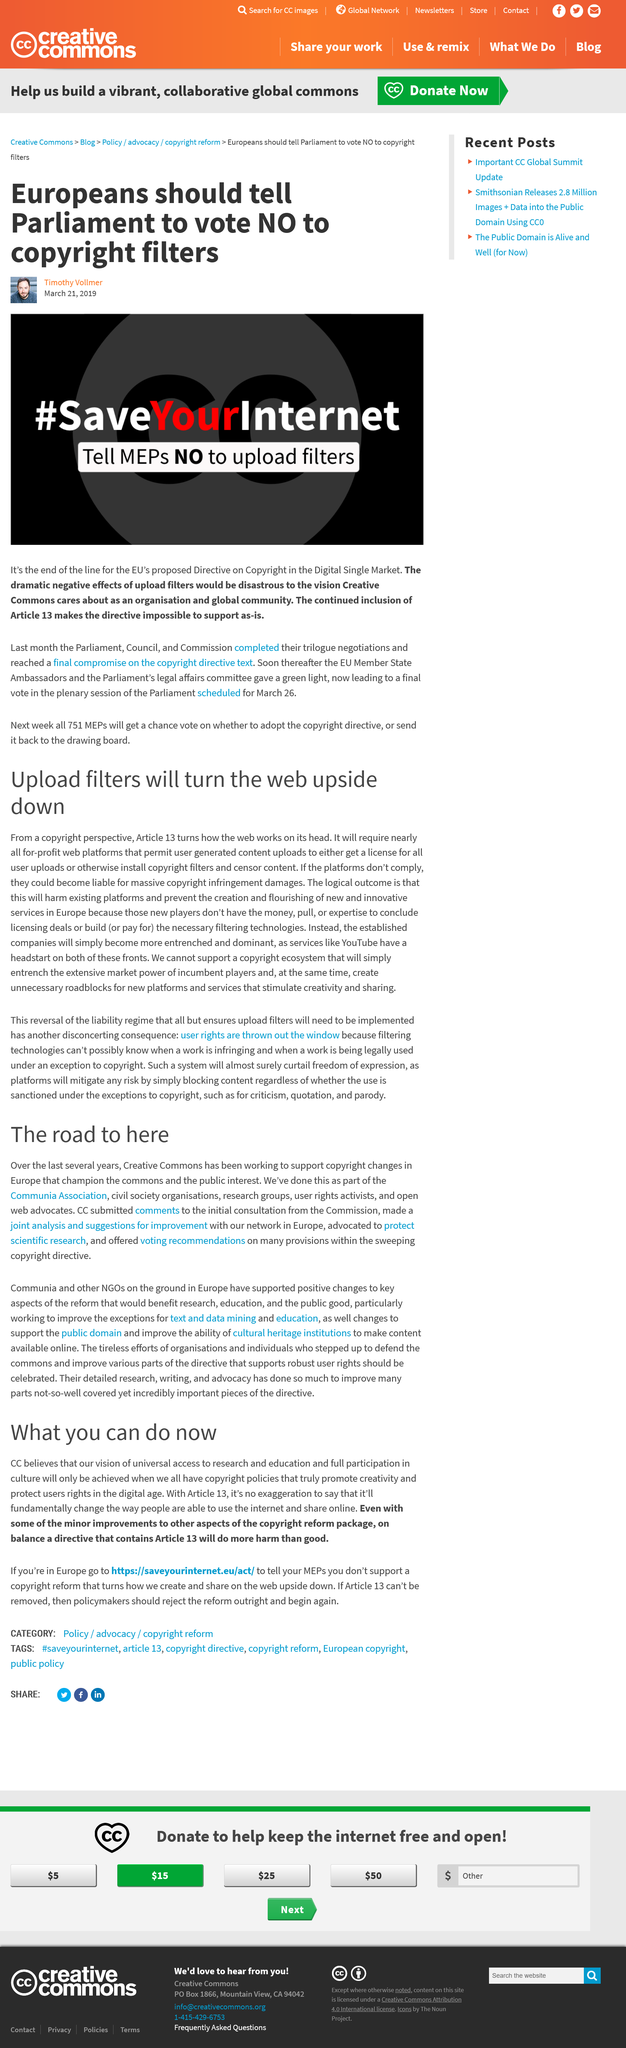Mention a couple of crucial points in this snapshot. Timothy Vollmer does not want the European Parliament to vote for or against the copyright filter. Since several years, Creative Commons has been working to promote copyright changes in Europe. The author believes that Article 13 will not improve the situation and will instead cause more harm than good. Creative Commons has been working towards supporting copyright changes in Europe that prioritize the commons and public interest over the past several years. On February 2019, the European Union Parliament, Council, and Commission reached a compromise on the copyright directive text. 